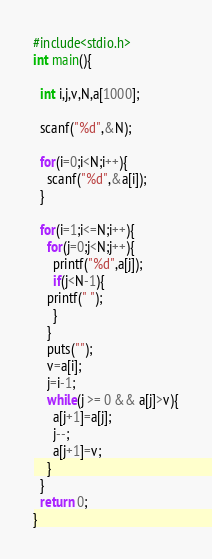<code> <loc_0><loc_0><loc_500><loc_500><_C_>#include<stdio.h>
int main(){

  int i,j,v,N,a[1000];

  scanf("%d",&N);

  for(i=0;i<N;i++){
    scanf("%d",&a[i]);
  }

  for(i=1;i<=N;i++){ 
    for(j=0;j<N;j++){
      printf("%d",a[j]);
      if(j<N-1){
	printf(" ");
      }
    }
    puts("");
    v=a[i];
    j=i-1;
    while(j >= 0 && a[j]>v){
      a[j+1]=a[j];
      j--;
      a[j+1]=v;
    }
  }
  return 0;
}</code> 